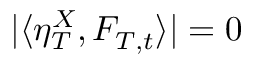Convert formula to latex. <formula><loc_0><loc_0><loc_500><loc_500>| \langle \eta _ { T } ^ { X } , F _ { T , t } \rangle | = 0</formula> 